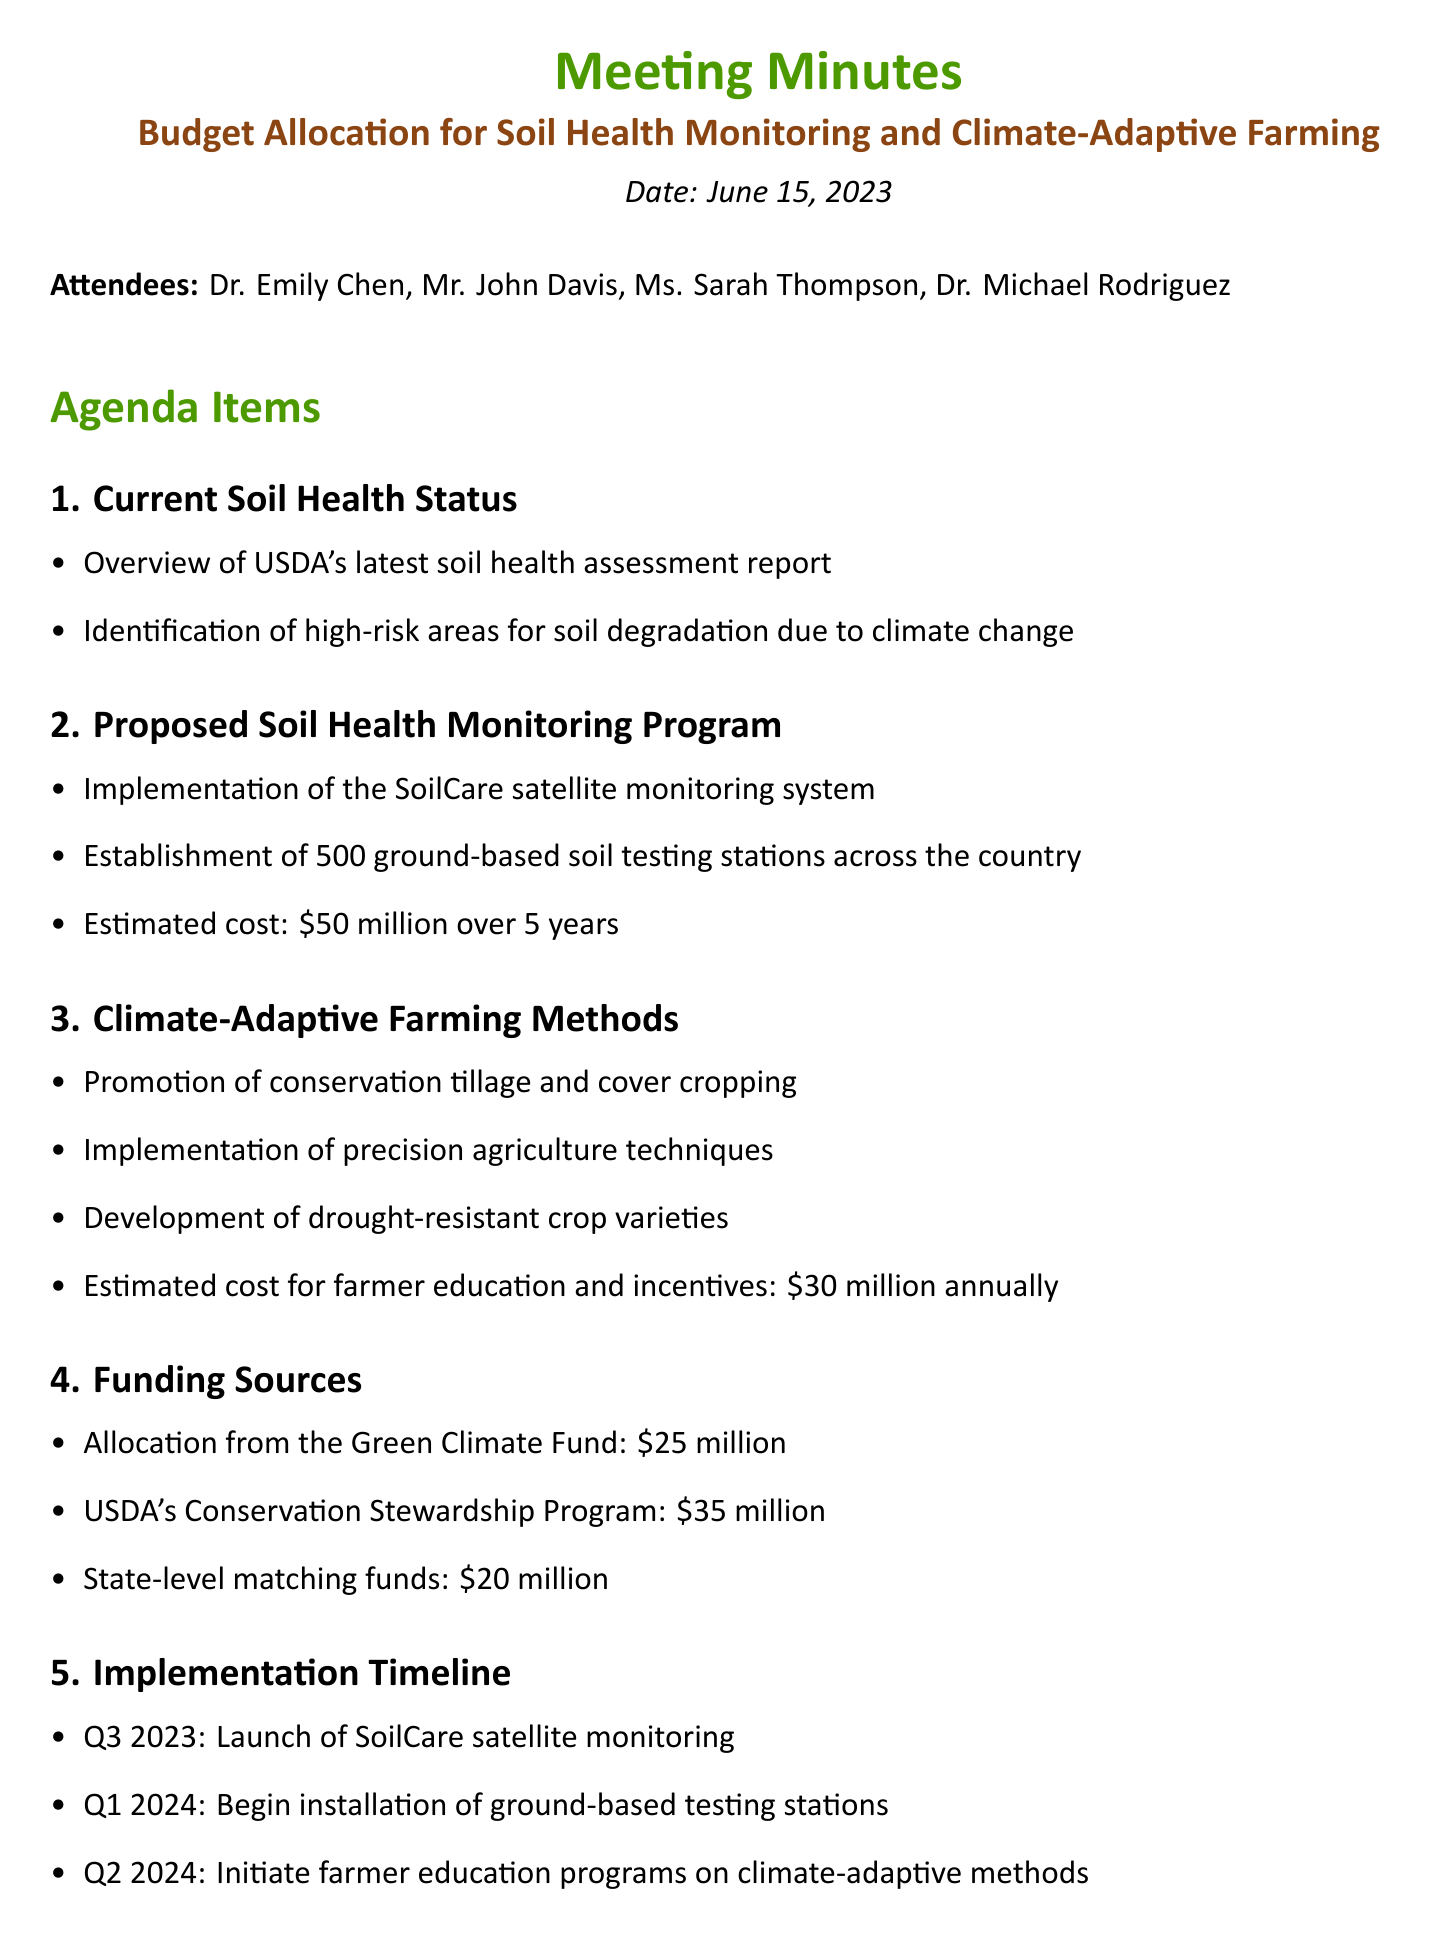What is the date of the meeting? The date of the meeting is explicitly stated in the document.
Answer: June 15, 2023 Who is the Chief Soil Scientist? The document lists attendees and their titles.
Answer: Dr. Emily Chen What is the estimated cost for the proposed Soil Health Monitoring Program? The document provides a specific cost for this program.
Answer: $50 million over 5 years How many ground-based soil testing stations are to be established? The number of stations is mentioned in the proposed program details.
Answer: 500 What is one of the methods promoted for climate-adaptive farming? The document lists various methods in the agenda item.
Answer: Conservation tillage What is the total funding from the Green Climate Fund and USDA's Conservation Stewardship Program? The total funding is calculated by adding the amounts allocated from these sources.
Answer: $60 million What is the first item on the implementation timeline? The implementation timeline is detailed in the agenda and specifies the first action.
Answer: Launch of SoilCare satellite monitoring Who is responsible for drafting a policy brief on incentives for climate-adaptive farming? The action items specify who is responsible for each task.
Answer: Ms. Thompson What quarter is the installation of ground-based testing stations scheduled to begin? The timeline section states the specific quarter for this event.
Answer: Q1 2024 